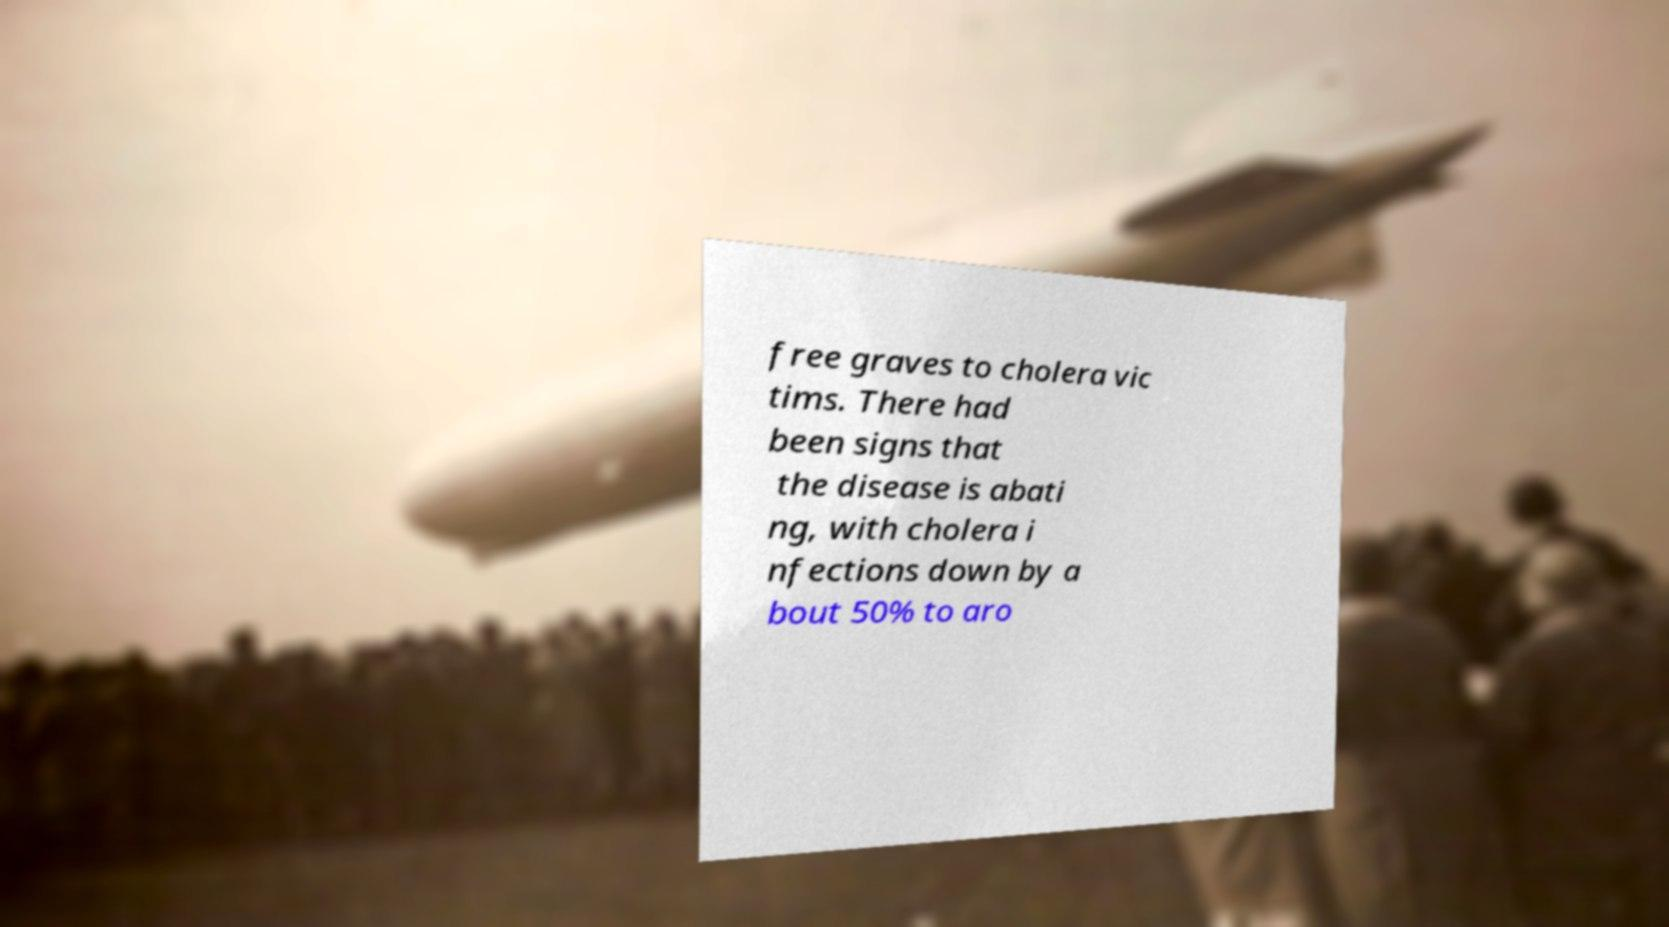Can you accurately transcribe the text from the provided image for me? free graves to cholera vic tims. There had been signs that the disease is abati ng, with cholera i nfections down by a bout 50% to aro 